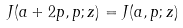Convert formula to latex. <formula><loc_0><loc_0><loc_500><loc_500>J ( a + 2 p , p ; z ) = J ( a , p ; z )</formula> 